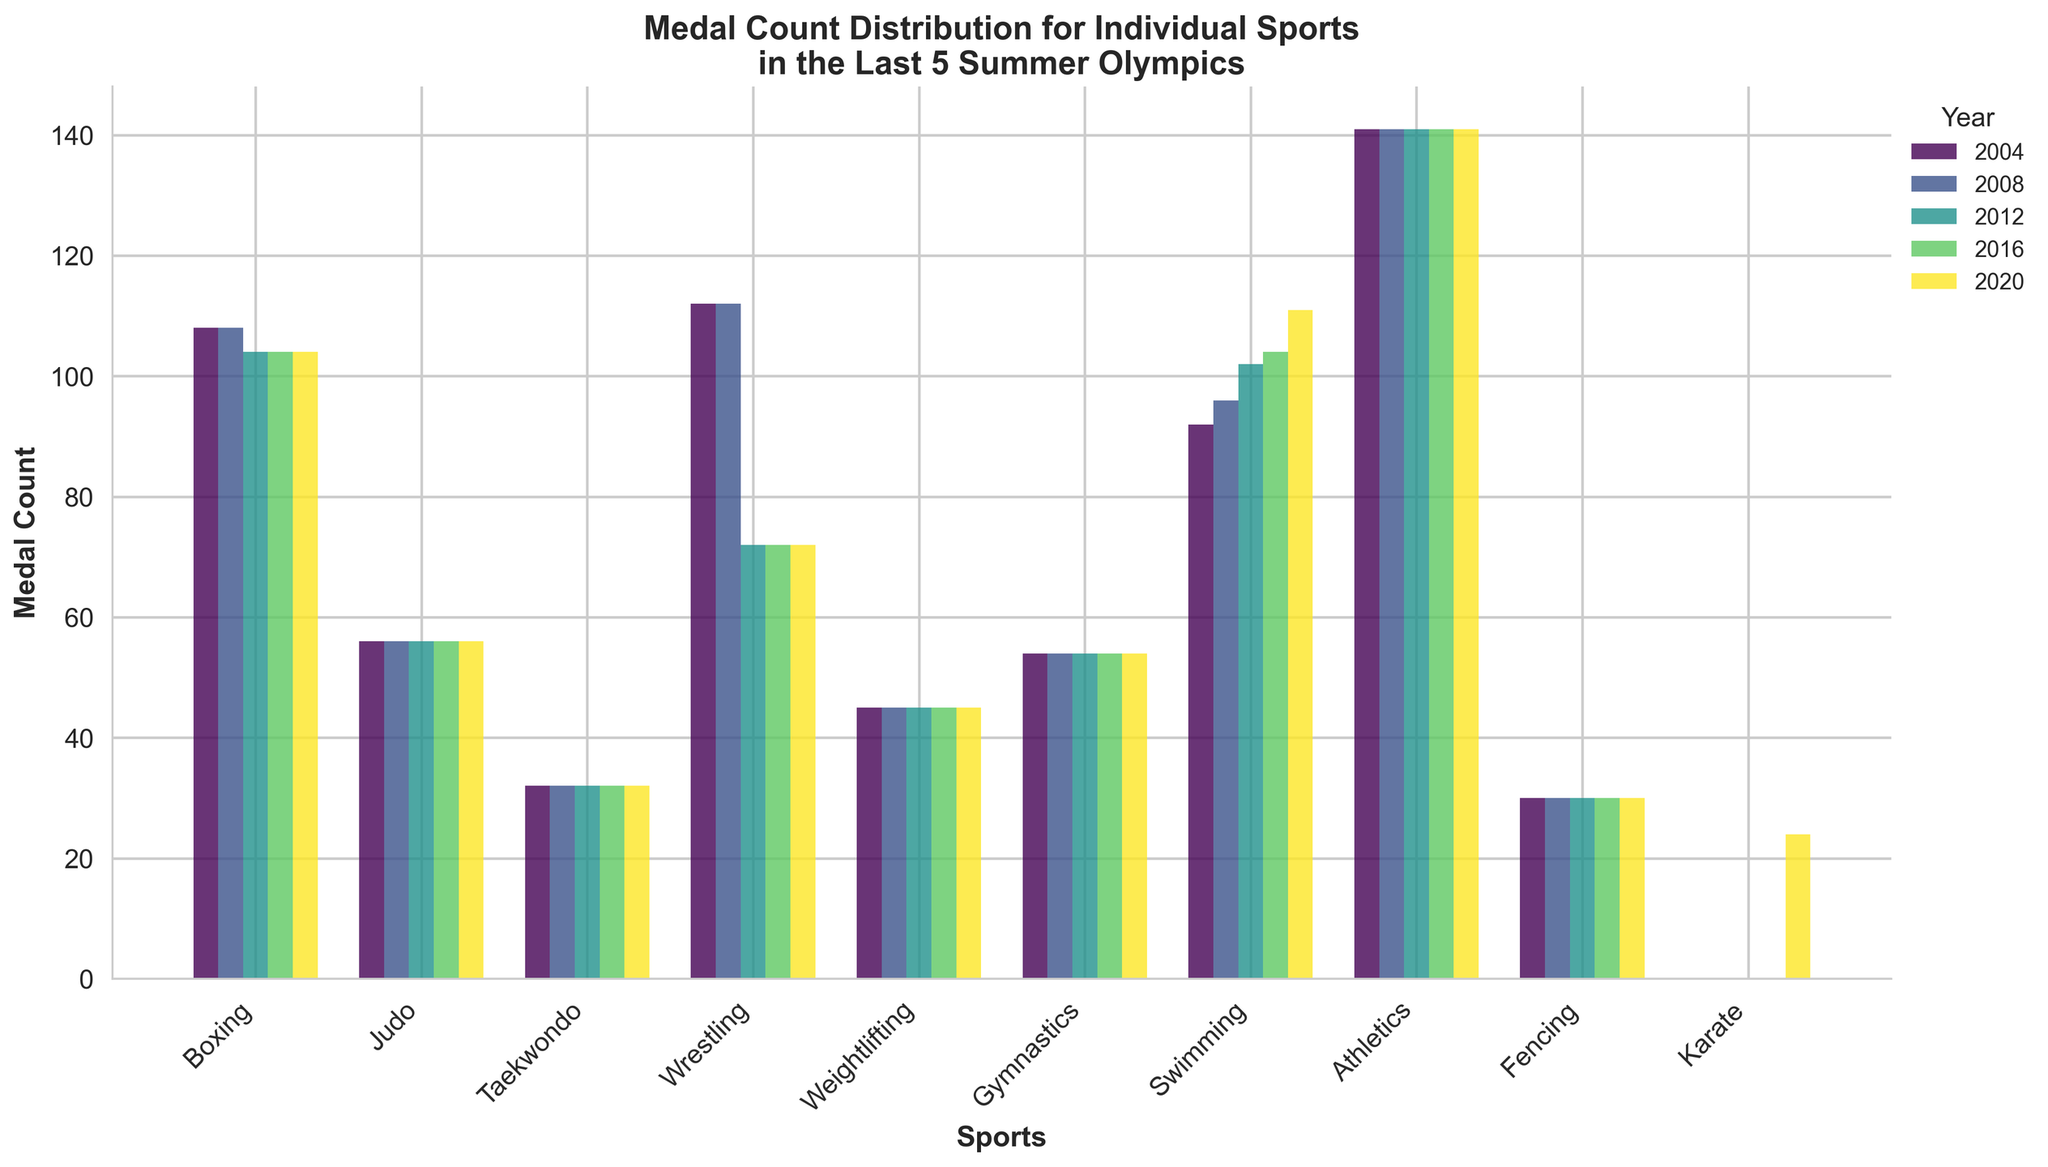What's the total number of medals won by Boxing across all 5 Olympics? Sum the Boxing column values for each Olympic year: 108 + 108 + 104 + 104 + 104 = 528
Answer: 528 Which sport had consistent medal counts across all 5 Olympics? Identify the sports columns where all five values are the same. Judo, Taekwondo, Weightlifting, Gymnastics, and Fencing have consistent medal counts.
Answer: Judo, Taekwondo, Weightlifting, Gymnastics, Fencing What is the average number of medals won by Wrestling in 2016 and 2020? Add the medal counts for 2016 and 2020 and then divide by 2: (72 + 72) / 2 = 72
Answer: 72 Which sport had the highest increase in medal count in 2020 compared to 2016? Compare the difference for each sport between 2016 and 2020. Karate increased from 0 to 24.
Answer: Karate In which year did Swimming see the largest number of medals won? Compare the Swimming bar heights (or values) for each year: 104 (2016) to 111 (2020).
Answer: 2020 How many more medals did Athletics win compared to Gymnastics in 2004? Subtract the medals of Gymnastics from Athletics: 141 - 54 = 87
Answer: 87 Which individual sport had the most variable medal counts over the 5 Olympics? Assess the difference between the highest and lowest counts for each sport. Wrestling varies from 112 to 72, a difference of 40. Boxing also has variation.
Answer: Wrestling, Boxing Did any sport have a decrease in medal counts from 2008 to 2012? Compare the medal counts for each sport from 2008 to 2012. Wrestling decreased from 112 to 72.
Answer: Wrestling What is the total number of medals in Taekwondo across all 5 Olympics? Sum the Taekwondo column values for each Olympic year: 32 + 32 + 32 + 32 + 32 = 160
Answer: 160 Which sport had the lowest medal count in any year? Identify the smallest value in the dataset. Karate had 0 medals before 2020.
Answer: Karate 